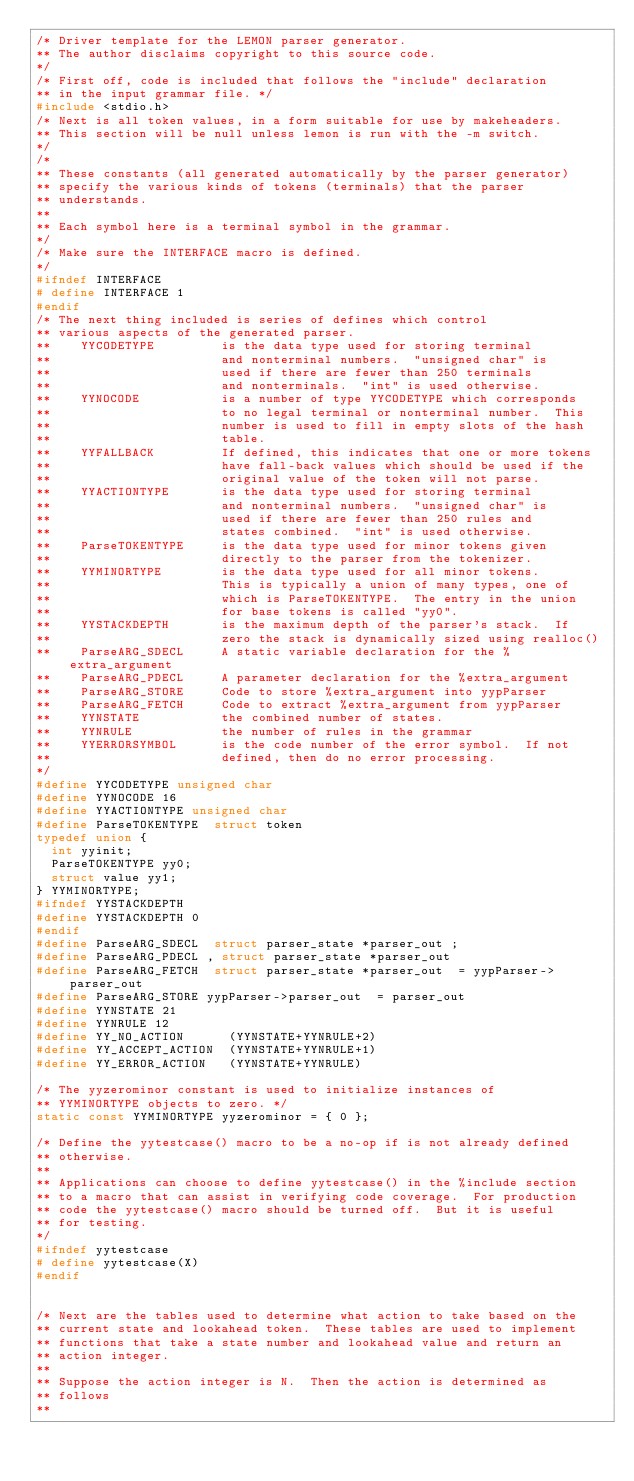<code> <loc_0><loc_0><loc_500><loc_500><_C_>/* Driver template for the LEMON parser generator.
** The author disclaims copyright to this source code.
*/
/* First off, code is included that follows the "include" declaration
** in the input grammar file. */
#include <stdio.h>
/* Next is all token values, in a form suitable for use by makeheaders.
** This section will be null unless lemon is run with the -m switch.
*/
/* 
** These constants (all generated automatically by the parser generator)
** specify the various kinds of tokens (terminals) that the parser
** understands. 
**
** Each symbol here is a terminal symbol in the grammar.
*/
/* Make sure the INTERFACE macro is defined.
*/
#ifndef INTERFACE
# define INTERFACE 1
#endif
/* The next thing included is series of defines which control
** various aspects of the generated parser.
**    YYCODETYPE         is the data type used for storing terminal
**                       and nonterminal numbers.  "unsigned char" is
**                       used if there are fewer than 250 terminals
**                       and nonterminals.  "int" is used otherwise.
**    YYNOCODE           is a number of type YYCODETYPE which corresponds
**                       to no legal terminal or nonterminal number.  This
**                       number is used to fill in empty slots of the hash 
**                       table.
**    YYFALLBACK         If defined, this indicates that one or more tokens
**                       have fall-back values which should be used if the
**                       original value of the token will not parse.
**    YYACTIONTYPE       is the data type used for storing terminal
**                       and nonterminal numbers.  "unsigned char" is
**                       used if there are fewer than 250 rules and
**                       states combined.  "int" is used otherwise.
**    ParseTOKENTYPE     is the data type used for minor tokens given 
**                       directly to the parser from the tokenizer.
**    YYMINORTYPE        is the data type used for all minor tokens.
**                       This is typically a union of many types, one of
**                       which is ParseTOKENTYPE.  The entry in the union
**                       for base tokens is called "yy0".
**    YYSTACKDEPTH       is the maximum depth of the parser's stack.  If
**                       zero the stack is dynamically sized using realloc()
**    ParseARG_SDECL     A static variable declaration for the %extra_argument
**    ParseARG_PDECL     A parameter declaration for the %extra_argument
**    ParseARG_STORE     Code to store %extra_argument into yypParser
**    ParseARG_FETCH     Code to extract %extra_argument from yypParser
**    YYNSTATE           the combined number of states.
**    YYNRULE            the number of rules in the grammar
**    YYERRORSYMBOL      is the code number of the error symbol.  If not
**                       defined, then do no error processing.
*/
#define YYCODETYPE unsigned char
#define YYNOCODE 16
#define YYACTIONTYPE unsigned char
#define ParseTOKENTYPE  struct token 
typedef union {
  int yyinit;
  ParseTOKENTYPE yy0;
  struct value yy1;
} YYMINORTYPE;
#ifndef YYSTACKDEPTH
#define YYSTACKDEPTH 0
#endif
#define ParseARG_SDECL  struct parser_state *parser_out ;
#define ParseARG_PDECL , struct parser_state *parser_out 
#define ParseARG_FETCH  struct parser_state *parser_out  = yypParser->parser_out 
#define ParseARG_STORE yypParser->parser_out  = parser_out 
#define YYNSTATE 21
#define YYNRULE 12
#define YY_NO_ACTION      (YYNSTATE+YYNRULE+2)
#define YY_ACCEPT_ACTION  (YYNSTATE+YYNRULE+1)
#define YY_ERROR_ACTION   (YYNSTATE+YYNRULE)

/* The yyzerominor constant is used to initialize instances of
** YYMINORTYPE objects to zero. */
static const YYMINORTYPE yyzerominor = { 0 };

/* Define the yytestcase() macro to be a no-op if is not already defined
** otherwise.
**
** Applications can choose to define yytestcase() in the %include section
** to a macro that can assist in verifying code coverage.  For production
** code the yytestcase() macro should be turned off.  But it is useful
** for testing.
*/
#ifndef yytestcase
# define yytestcase(X)
#endif


/* Next are the tables used to determine what action to take based on the
** current state and lookahead token.  These tables are used to implement
** functions that take a state number and lookahead value and return an
** action integer.  
**
** Suppose the action integer is N.  Then the action is determined as
** follows
**</code> 